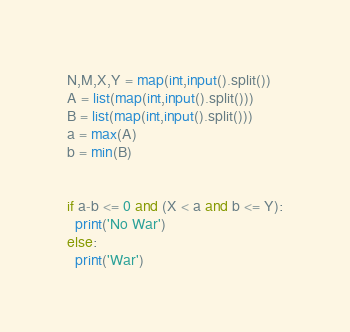<code> <loc_0><loc_0><loc_500><loc_500><_Python_>N,M,X,Y = map(int,input().split())
A = list(map(int,input().split()))
B = list(map(int,input().split()))
a = max(A)
b = min(B)


if a-b <= 0 and (X < a and b <= Y):
  print('No War')
else:
  print('War')</code> 